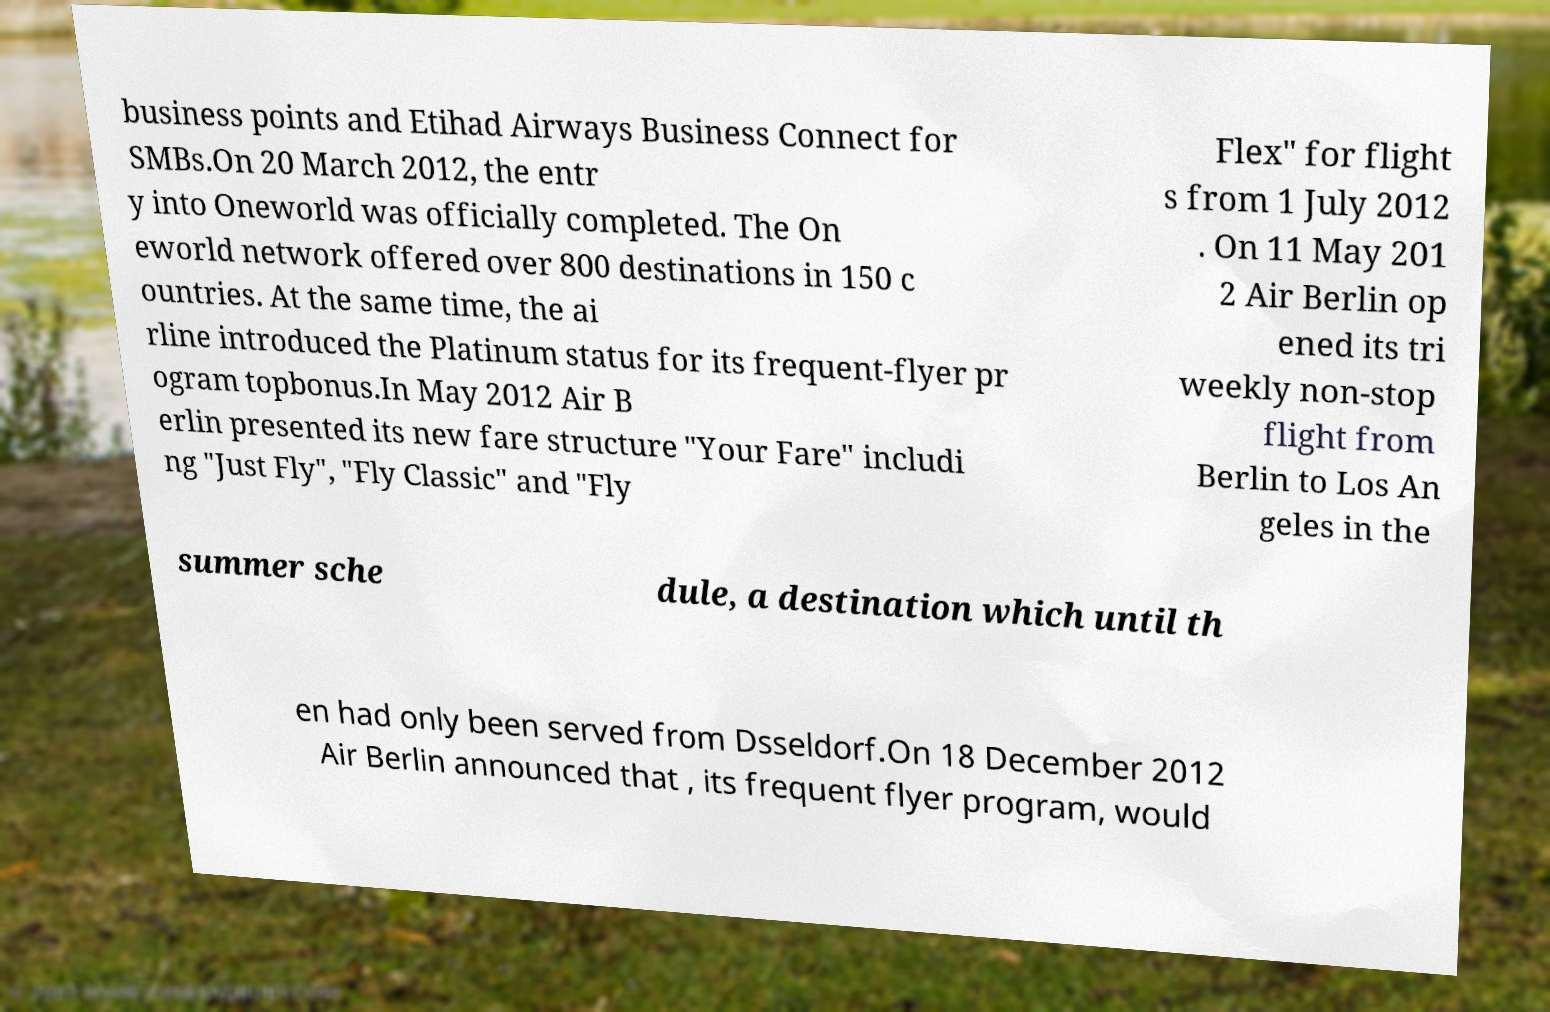I need the written content from this picture converted into text. Can you do that? business points and Etihad Airways Business Connect for SMBs.On 20 March 2012, the entr y into Oneworld was officially completed. The On eworld network offered over 800 destinations in 150 c ountries. At the same time, the ai rline introduced the Platinum status for its frequent-flyer pr ogram topbonus.In May 2012 Air B erlin presented its new fare structure "Your Fare" includi ng "Just Fly", "Fly Classic" and "Fly Flex" for flight s from 1 July 2012 . On 11 May 201 2 Air Berlin op ened its tri weekly non-stop flight from Berlin to Los An geles in the summer sche dule, a destination which until th en had only been served from Dsseldorf.On 18 December 2012 Air Berlin announced that , its frequent flyer program, would 